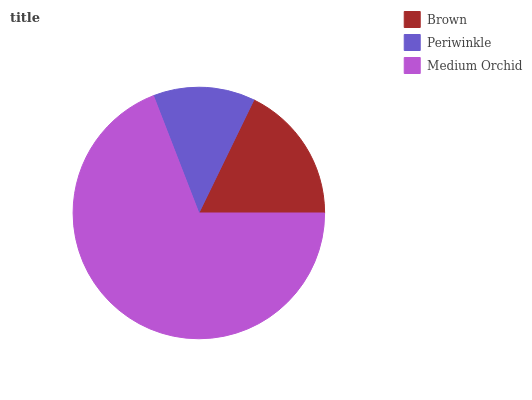Is Periwinkle the minimum?
Answer yes or no. Yes. Is Medium Orchid the maximum?
Answer yes or no. Yes. Is Medium Orchid the minimum?
Answer yes or no. No. Is Periwinkle the maximum?
Answer yes or no. No. Is Medium Orchid greater than Periwinkle?
Answer yes or no. Yes. Is Periwinkle less than Medium Orchid?
Answer yes or no. Yes. Is Periwinkle greater than Medium Orchid?
Answer yes or no. No. Is Medium Orchid less than Periwinkle?
Answer yes or no. No. Is Brown the high median?
Answer yes or no. Yes. Is Brown the low median?
Answer yes or no. Yes. Is Medium Orchid the high median?
Answer yes or no. No. Is Medium Orchid the low median?
Answer yes or no. No. 